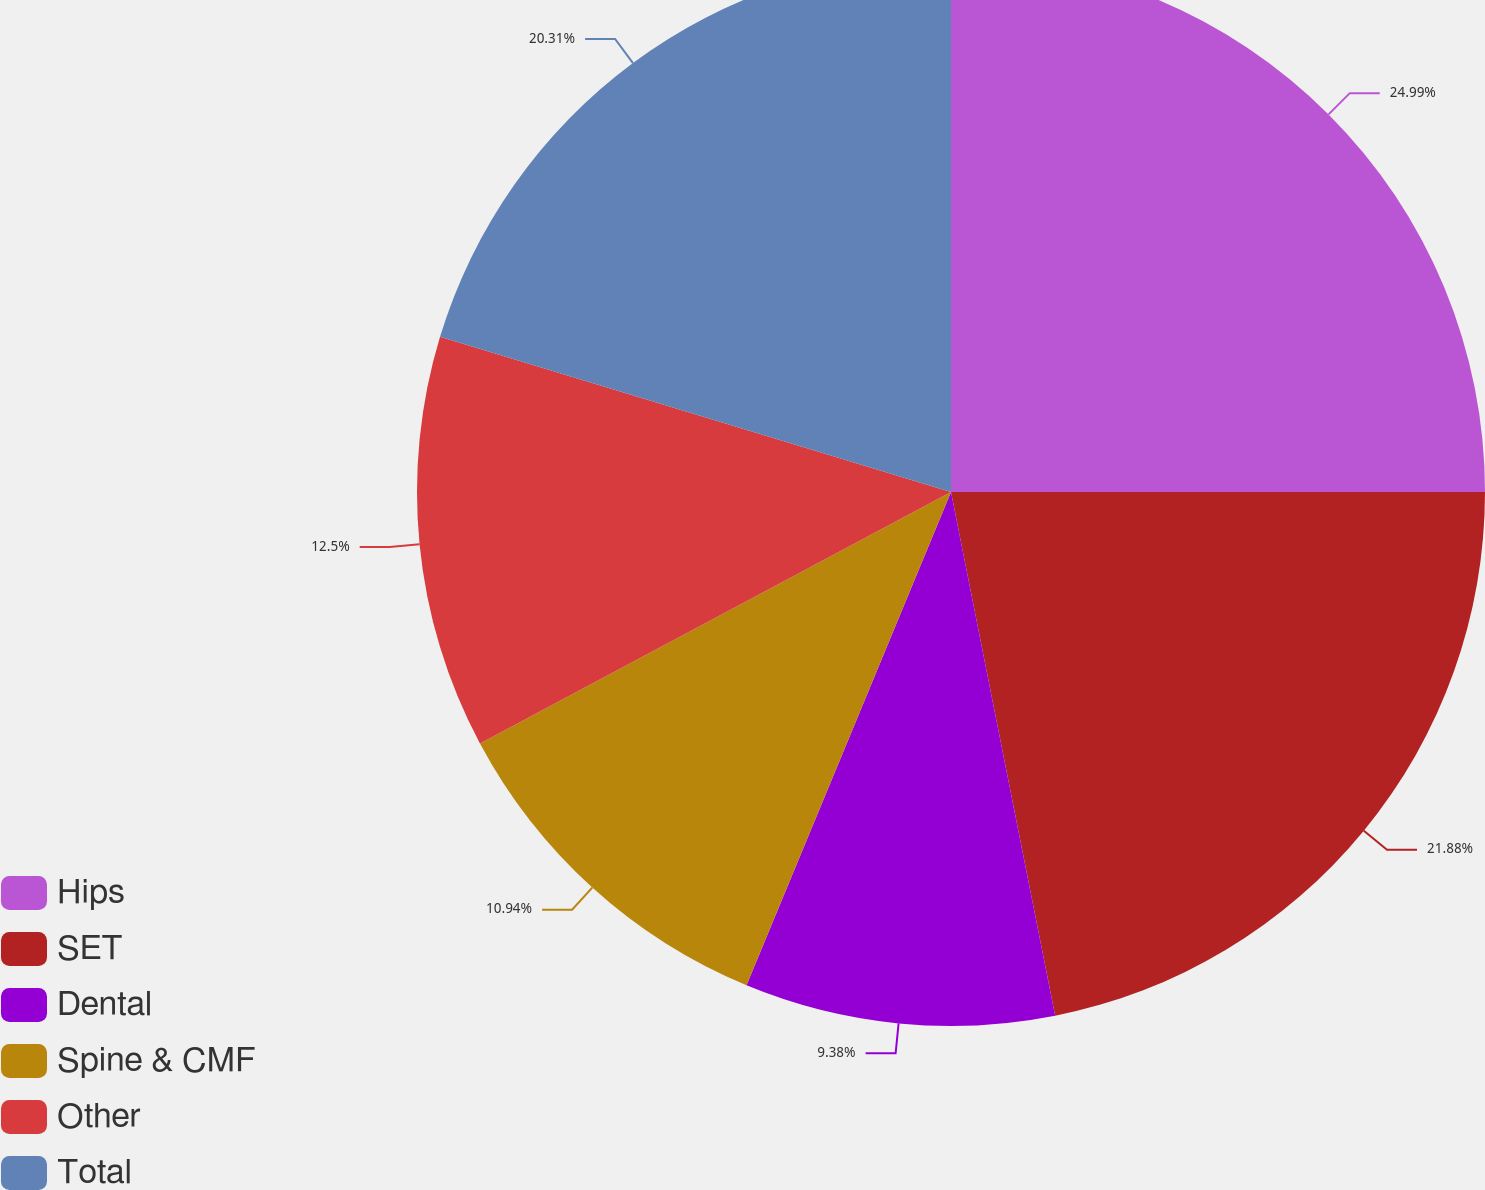Convert chart to OTSL. <chart><loc_0><loc_0><loc_500><loc_500><pie_chart><fcel>Hips<fcel>SET<fcel>Dental<fcel>Spine & CMF<fcel>Other<fcel>Total<nl><fcel>25.0%<fcel>21.88%<fcel>9.38%<fcel>10.94%<fcel>12.5%<fcel>20.31%<nl></chart> 